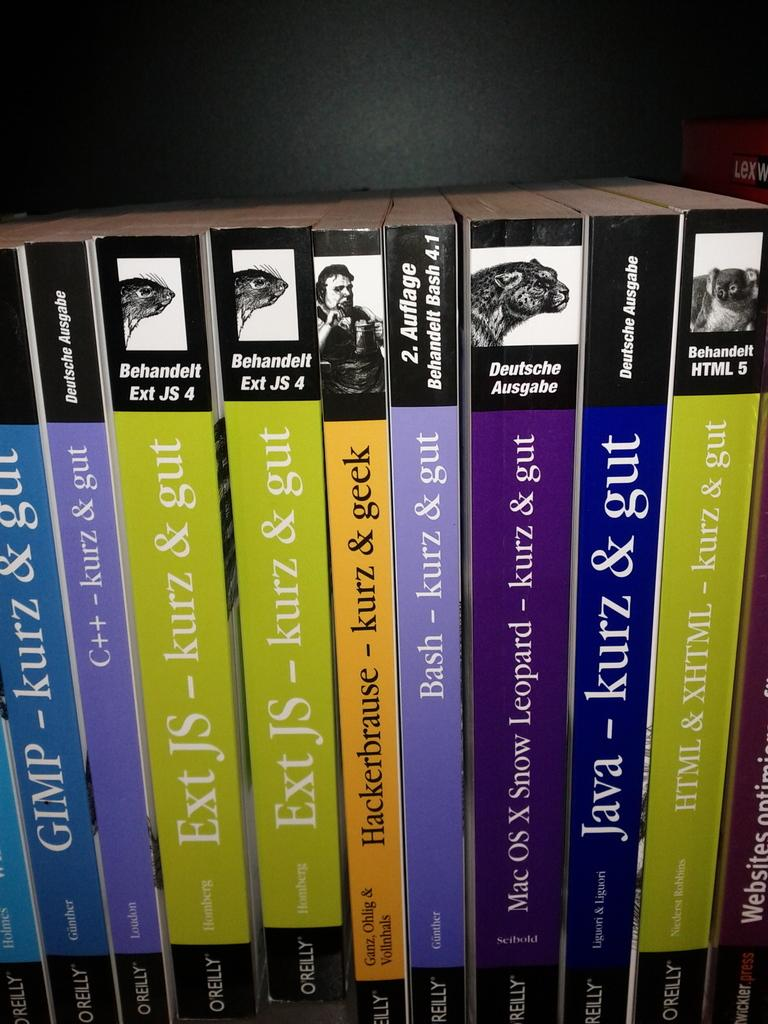<image>
Describe the image concisely. A self lined with several computer books including one for JAVA. 